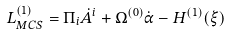Convert formula to latex. <formula><loc_0><loc_0><loc_500><loc_500>L _ { M C S } ^ { ( 1 ) } = \Pi _ { i } \dot { A } ^ { i } + \Omega ^ { ( 0 ) } \dot { \alpha } - H ^ { ( 1 ) } ( \xi )</formula> 